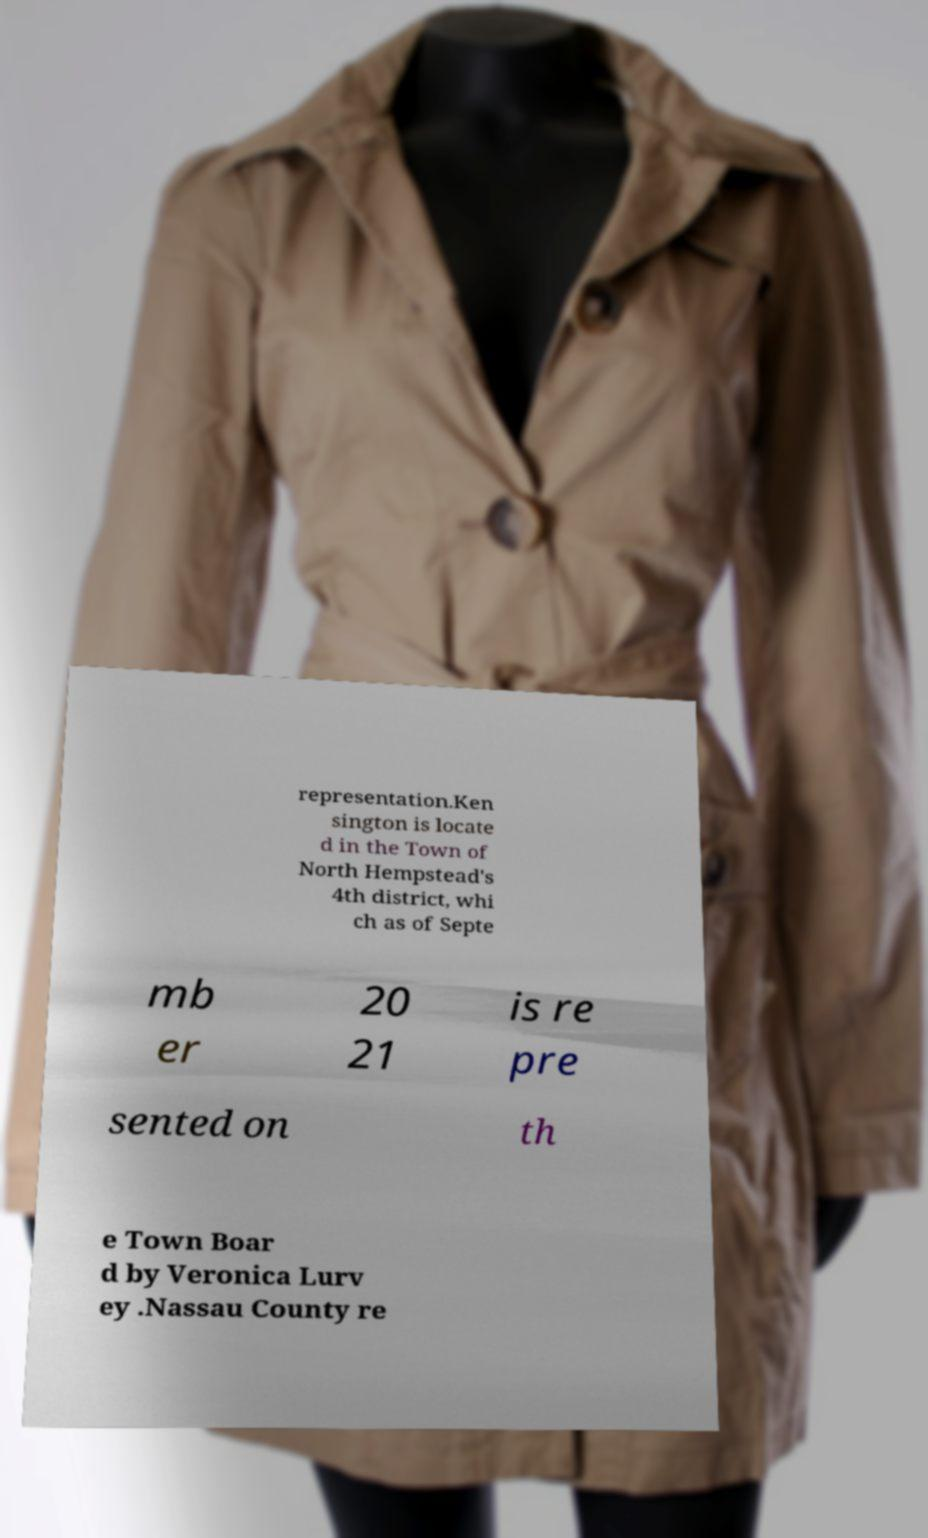What messages or text are displayed in this image? I need them in a readable, typed format. representation.Ken sington is locate d in the Town of North Hempstead's 4th district, whi ch as of Septe mb er 20 21 is re pre sented on th e Town Boar d by Veronica Lurv ey .Nassau County re 